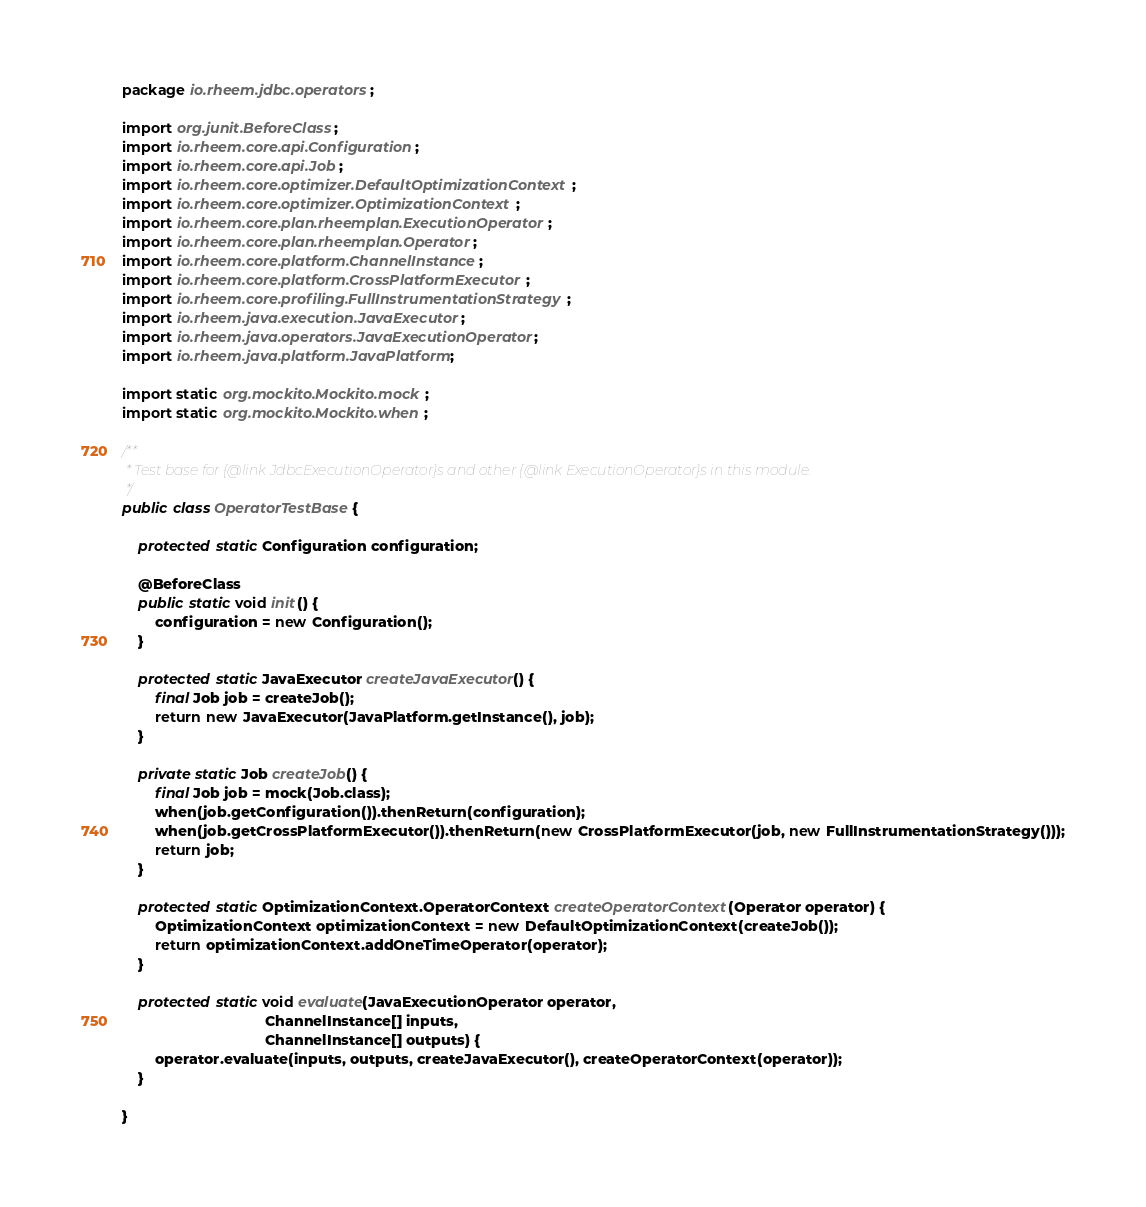Convert code to text. <code><loc_0><loc_0><loc_500><loc_500><_Java_>package io.rheem.jdbc.operators;

import org.junit.BeforeClass;
import io.rheem.core.api.Configuration;
import io.rheem.core.api.Job;
import io.rheem.core.optimizer.DefaultOptimizationContext;
import io.rheem.core.optimizer.OptimizationContext;
import io.rheem.core.plan.rheemplan.ExecutionOperator;
import io.rheem.core.plan.rheemplan.Operator;
import io.rheem.core.platform.ChannelInstance;
import io.rheem.core.platform.CrossPlatformExecutor;
import io.rheem.core.profiling.FullInstrumentationStrategy;
import io.rheem.java.execution.JavaExecutor;
import io.rheem.java.operators.JavaExecutionOperator;
import io.rheem.java.platform.JavaPlatform;

import static org.mockito.Mockito.mock;
import static org.mockito.Mockito.when;

/**
 * Test base for {@link JdbcExecutionOperator}s and other {@link ExecutionOperator}s in this module.
 */
public class OperatorTestBase {

    protected static Configuration configuration;

    @BeforeClass
    public static void init() {
        configuration = new Configuration();
    }

    protected static JavaExecutor createJavaExecutor() {
        final Job job = createJob();
        return new JavaExecutor(JavaPlatform.getInstance(), job);
    }

    private static Job createJob() {
        final Job job = mock(Job.class);
        when(job.getConfiguration()).thenReturn(configuration);
        when(job.getCrossPlatformExecutor()).thenReturn(new CrossPlatformExecutor(job, new FullInstrumentationStrategy()));
        return job;
    }

    protected static OptimizationContext.OperatorContext createOperatorContext(Operator operator) {
        OptimizationContext optimizationContext = new DefaultOptimizationContext(createJob());
        return optimizationContext.addOneTimeOperator(operator);
    }

    protected static void evaluate(JavaExecutionOperator operator,
                                   ChannelInstance[] inputs,
                                   ChannelInstance[] outputs) {
        operator.evaluate(inputs, outputs, createJavaExecutor(), createOperatorContext(operator));
    }

}
</code> 